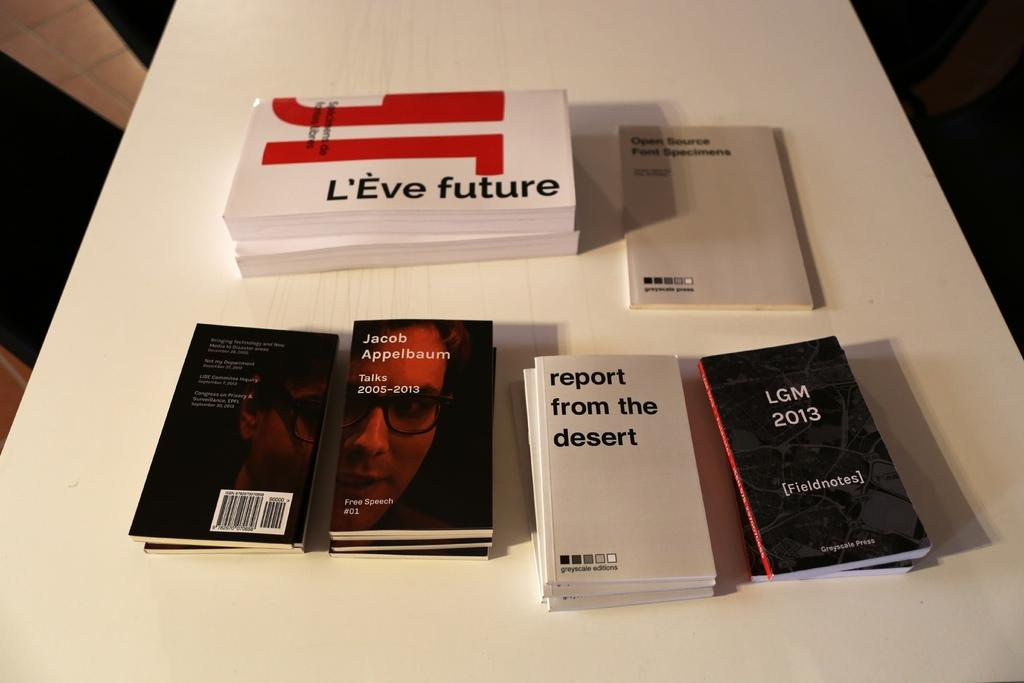What objects are on the table in the image? There are books on a table in the image. Can you describe the table? The table is white. What can be seen on the book covers? The book covers have photos of people on them and there is writing on the book covers. What type of spark can be seen coming from the books in the image? There is no spark present in the image; the books are stationary on the table. 